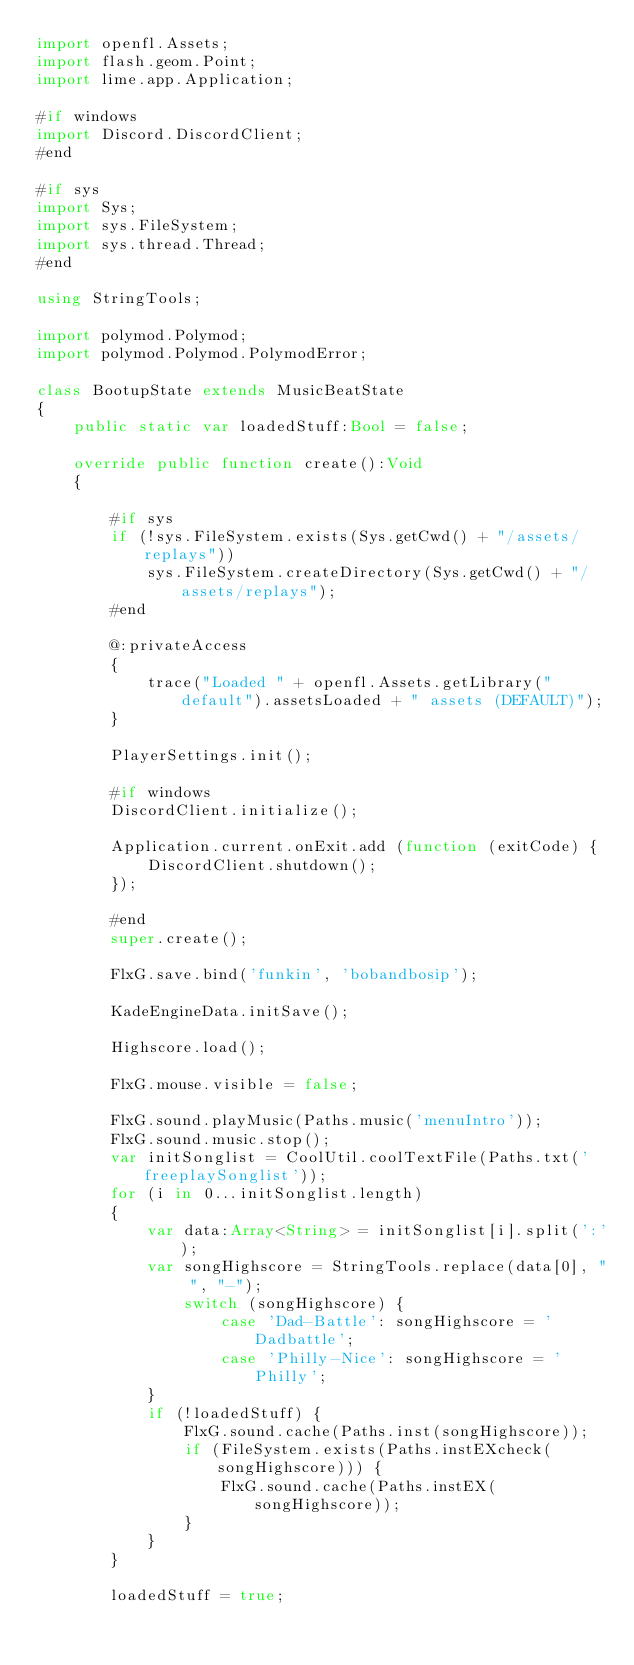<code> <loc_0><loc_0><loc_500><loc_500><_Haxe_>import openfl.Assets;
import flash.geom.Point;
import lime.app.Application;

#if windows
import Discord.DiscordClient;
#end

#if sys 
import Sys;
import sys.FileSystem;
import sys.thread.Thread;
#end

using StringTools;

import polymod.Polymod;
import polymod.Polymod.PolymodError;

class BootupState extends MusicBeatState
{
	public static var loadedStuff:Bool = false;

	override public function create():Void
	{
		
		#if sys
		if (!sys.FileSystem.exists(Sys.getCwd() + "/assets/replays"))
			sys.FileSystem.createDirectory(Sys.getCwd() + "/assets/replays");
		#end

		@:privateAccess
		{
			trace("Loaded " + openfl.Assets.getLibrary("default").assetsLoaded + " assets (DEFAULT)");
		}
		
		PlayerSettings.init();

		#if windows
		DiscordClient.initialize();

		Application.current.onExit.add (function (exitCode) {
			DiscordClient.shutdown();
		});
		 
		#end
		super.create();

		FlxG.save.bind('funkin', 'bobandbosip');

		KadeEngineData.initSave();

		Highscore.load();

		FlxG.mouse.visible = false;

		FlxG.sound.playMusic(Paths.music('menuIntro'));
		FlxG.sound.music.stop();
		var initSonglist = CoolUtil.coolTextFile(Paths.txt('freeplaySonglist'));
		for (i in 0...initSonglist.length)
		{
			var data:Array<String> = initSonglist[i].split(':');
			var songHighscore = StringTools.replace(data[0], " ", "-");
				switch (songHighscore) {
					case 'Dad-Battle': songHighscore = 'Dadbattle';
					case 'Philly-Nice': songHighscore = 'Philly';
			}
			if (!loadedStuff) {
				FlxG.sound.cache(Paths.inst(songHighscore));
				if (FileSystem.exists(Paths.instEXcheck(songHighscore))) {
					FlxG.sound.cache(Paths.instEX(songHighscore));
				}
			}
		}
		
		loadedStuff = true;
</code> 